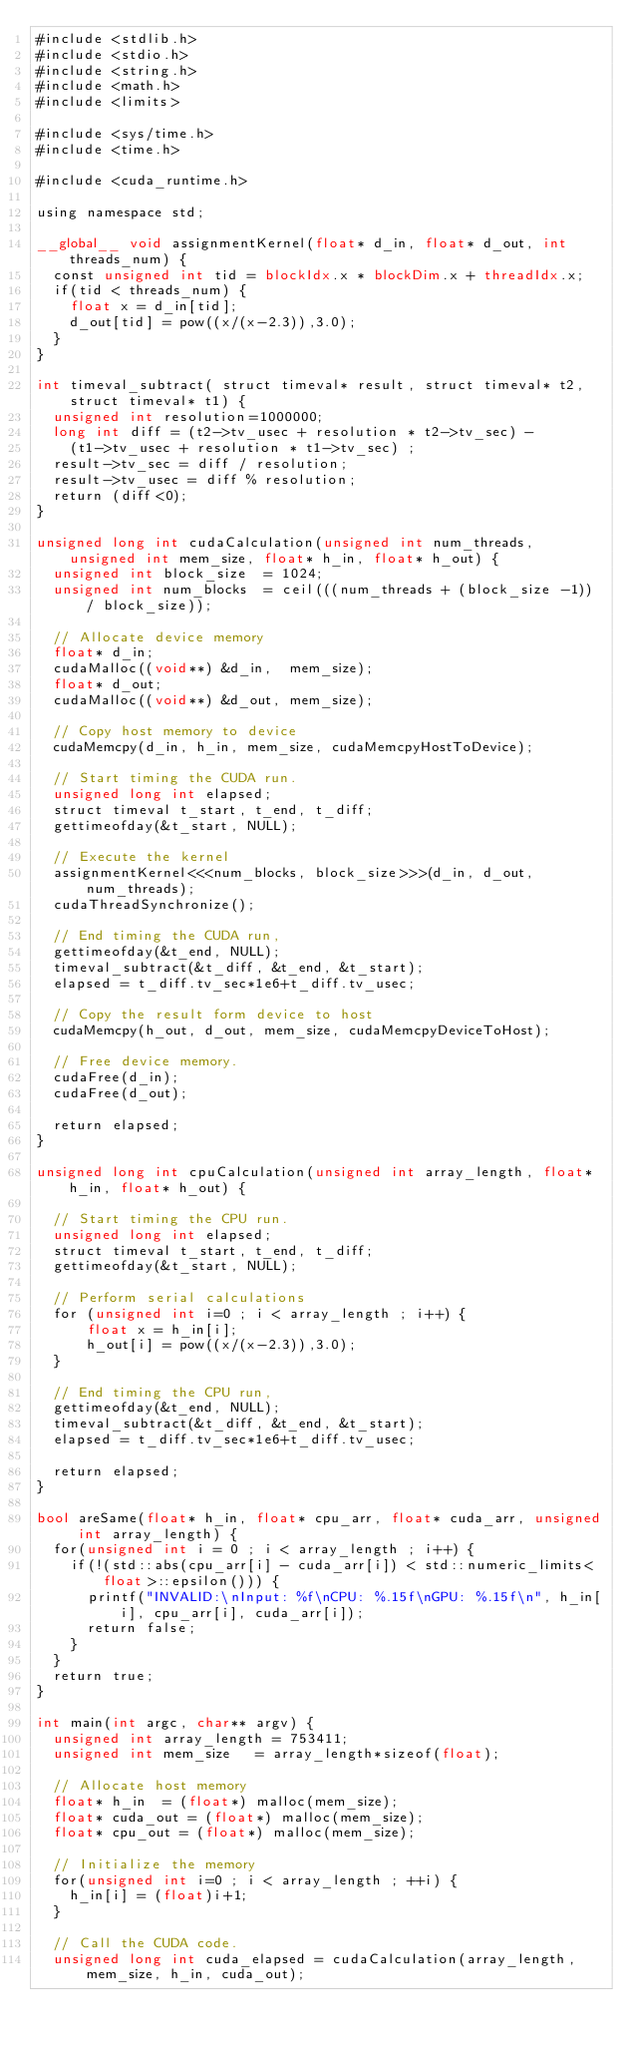Convert code to text. <code><loc_0><loc_0><loc_500><loc_500><_Cuda_>#include <stdlib.h>
#include <stdio.h>
#include <string.h>
#include <math.h>
#include <limits>

#include <sys/time.h>
#include <time.h>

#include <cuda_runtime.h>

using namespace std;

__global__ void assignmentKernel(float* d_in, float* d_out, int threads_num) {
  const unsigned int tid = blockIdx.x * blockDim.x + threadIdx.x;
  if(tid < threads_num) {
    float x = d_in[tid];
    d_out[tid] = pow((x/(x-2.3)),3.0);
  }
}

int timeval_subtract( struct timeval* result, struct timeval* t2,struct timeval* t1) {
  unsigned int resolution=1000000;
  long int diff = (t2->tv_usec + resolution * t2->tv_sec) -
    (t1->tv_usec + resolution * t1->tv_sec) ;
  result->tv_sec = diff / resolution;
  result->tv_usec = diff % resolution;
  return (diff<0);
}

unsigned long int cudaCalculation(unsigned int num_threads, unsigned int mem_size, float* h_in, float* h_out) {
  unsigned int block_size  = 1024;
  unsigned int num_blocks  = ceil(((num_threads + (block_size -1)) / block_size));

  // Allocate device memory
  float* d_in;
  cudaMalloc((void**) &d_in,  mem_size);
  float* d_out;
  cudaMalloc((void**) &d_out, mem_size);

  // Copy host memory to device
  cudaMemcpy(d_in, h_in, mem_size, cudaMemcpyHostToDevice);

  // Start timing the CUDA run.
  unsigned long int elapsed;
  struct timeval t_start, t_end, t_diff;
  gettimeofday(&t_start, NULL);

  // Execute the kernel
  assignmentKernel<<<num_blocks, block_size>>>(d_in, d_out, num_threads);
  cudaThreadSynchronize();

  // End timing the CUDA run,
  gettimeofday(&t_end, NULL);
  timeval_subtract(&t_diff, &t_end, &t_start);
  elapsed = t_diff.tv_sec*1e6+t_diff.tv_usec;

  // Copy the result form device to host
  cudaMemcpy(h_out, d_out, mem_size, cudaMemcpyDeviceToHost);

  // Free device memory.
  cudaFree(d_in);
  cudaFree(d_out);

  return elapsed;
}

unsigned long int cpuCalculation(unsigned int array_length, float* h_in, float* h_out) {

  // Start timing the CPU run.
  unsigned long int elapsed;
  struct timeval t_start, t_end, t_diff;
  gettimeofday(&t_start, NULL);

  // Perform serial calculations
  for (unsigned int i=0 ; i < array_length ; i++) {
      float x = h_in[i];
      h_out[i] = pow((x/(x-2.3)),3.0);
  }

  // End timing the CPU run,
  gettimeofday(&t_end, NULL);
  timeval_subtract(&t_diff, &t_end, &t_start);
  elapsed = t_diff.tv_sec*1e6+t_diff.tv_usec;

  return elapsed;
}

bool areSame(float* h_in, float* cpu_arr, float* cuda_arr, unsigned int array_length) {
  for(unsigned int i = 0 ; i < array_length ; i++) {
    if(!(std::abs(cpu_arr[i] - cuda_arr[i]) < std::numeric_limits<float>::epsilon())) {
      printf("INVALID:\nInput: %f\nCPU: %.15f\nGPU: %.15f\n", h_in[i], cpu_arr[i], cuda_arr[i]);
      return false;
    }
  }
  return true;
}

int main(int argc, char** argv) {
  unsigned int array_length = 753411;
  unsigned int mem_size   = array_length*sizeof(float);

  // Allocate host memory
  float* h_in  = (float*) malloc(mem_size);
  float* cuda_out = (float*) malloc(mem_size);
  float* cpu_out = (float*) malloc(mem_size);

  // Initialize the memory
  for(unsigned int i=0 ; i < array_length ; ++i) {
    h_in[i] = (float)i+1;
  }

  // Call the CUDA code.
  unsigned long int cuda_elapsed = cudaCalculation(array_length, mem_size, h_in, cuda_out);</code> 